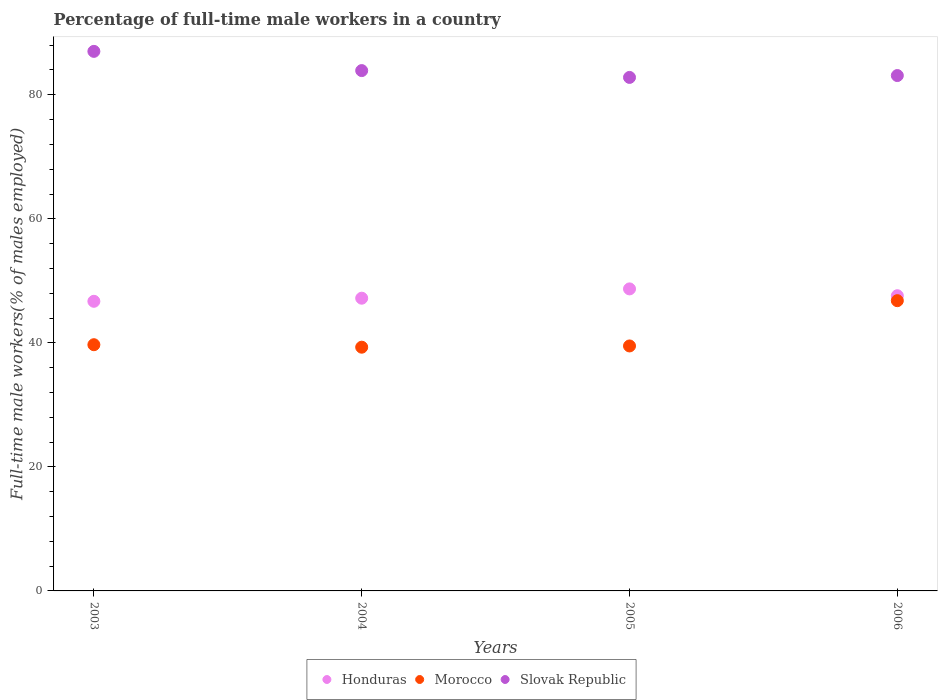How many different coloured dotlines are there?
Provide a short and direct response. 3. Is the number of dotlines equal to the number of legend labels?
Your response must be concise. Yes. What is the percentage of full-time male workers in Morocco in 2004?
Provide a short and direct response. 39.3. Across all years, what is the maximum percentage of full-time male workers in Honduras?
Keep it short and to the point. 48.7. Across all years, what is the minimum percentage of full-time male workers in Morocco?
Your answer should be compact. 39.3. In which year was the percentage of full-time male workers in Slovak Republic maximum?
Give a very brief answer. 2003. In which year was the percentage of full-time male workers in Honduras minimum?
Offer a very short reply. 2003. What is the total percentage of full-time male workers in Honduras in the graph?
Give a very brief answer. 190.2. What is the difference between the percentage of full-time male workers in Slovak Republic in 2004 and that in 2005?
Your response must be concise. 1.1. What is the difference between the percentage of full-time male workers in Morocco in 2006 and the percentage of full-time male workers in Honduras in 2005?
Your answer should be compact. -1.9. What is the average percentage of full-time male workers in Slovak Republic per year?
Provide a short and direct response. 84.2. In the year 2004, what is the difference between the percentage of full-time male workers in Honduras and percentage of full-time male workers in Morocco?
Ensure brevity in your answer.  7.9. What is the ratio of the percentage of full-time male workers in Slovak Republic in 2004 to that in 2005?
Offer a terse response. 1.01. Is the difference between the percentage of full-time male workers in Honduras in 2003 and 2004 greater than the difference between the percentage of full-time male workers in Morocco in 2003 and 2004?
Provide a short and direct response. No. What is the difference between the highest and the second highest percentage of full-time male workers in Honduras?
Provide a succinct answer. 1.1. What is the difference between the highest and the lowest percentage of full-time male workers in Slovak Republic?
Offer a very short reply. 4.2. Is the sum of the percentage of full-time male workers in Slovak Republic in 2003 and 2005 greater than the maximum percentage of full-time male workers in Honduras across all years?
Make the answer very short. Yes. Is it the case that in every year, the sum of the percentage of full-time male workers in Honduras and percentage of full-time male workers in Slovak Republic  is greater than the percentage of full-time male workers in Morocco?
Offer a terse response. Yes. Does the percentage of full-time male workers in Morocco monotonically increase over the years?
Your response must be concise. No. Is the percentage of full-time male workers in Slovak Republic strictly less than the percentage of full-time male workers in Morocco over the years?
Make the answer very short. No. How many dotlines are there?
Make the answer very short. 3. How many years are there in the graph?
Your answer should be compact. 4. What is the difference between two consecutive major ticks on the Y-axis?
Ensure brevity in your answer.  20. Does the graph contain grids?
Provide a short and direct response. No. Where does the legend appear in the graph?
Ensure brevity in your answer.  Bottom center. How are the legend labels stacked?
Your response must be concise. Horizontal. What is the title of the graph?
Provide a succinct answer. Percentage of full-time male workers in a country. Does "Guyana" appear as one of the legend labels in the graph?
Give a very brief answer. No. What is the label or title of the X-axis?
Keep it short and to the point. Years. What is the label or title of the Y-axis?
Offer a very short reply. Full-time male workers(% of males employed). What is the Full-time male workers(% of males employed) of Honduras in 2003?
Your response must be concise. 46.7. What is the Full-time male workers(% of males employed) in Morocco in 2003?
Your response must be concise. 39.7. What is the Full-time male workers(% of males employed) of Slovak Republic in 2003?
Your response must be concise. 87. What is the Full-time male workers(% of males employed) in Honduras in 2004?
Keep it short and to the point. 47.2. What is the Full-time male workers(% of males employed) in Morocco in 2004?
Offer a very short reply. 39.3. What is the Full-time male workers(% of males employed) of Slovak Republic in 2004?
Your answer should be very brief. 83.9. What is the Full-time male workers(% of males employed) in Honduras in 2005?
Give a very brief answer. 48.7. What is the Full-time male workers(% of males employed) of Morocco in 2005?
Provide a succinct answer. 39.5. What is the Full-time male workers(% of males employed) in Slovak Republic in 2005?
Your answer should be compact. 82.8. What is the Full-time male workers(% of males employed) in Honduras in 2006?
Ensure brevity in your answer.  47.6. What is the Full-time male workers(% of males employed) in Morocco in 2006?
Make the answer very short. 46.8. What is the Full-time male workers(% of males employed) of Slovak Republic in 2006?
Your answer should be compact. 83.1. Across all years, what is the maximum Full-time male workers(% of males employed) of Honduras?
Keep it short and to the point. 48.7. Across all years, what is the maximum Full-time male workers(% of males employed) in Morocco?
Provide a short and direct response. 46.8. Across all years, what is the maximum Full-time male workers(% of males employed) of Slovak Republic?
Provide a short and direct response. 87. Across all years, what is the minimum Full-time male workers(% of males employed) in Honduras?
Your answer should be compact. 46.7. Across all years, what is the minimum Full-time male workers(% of males employed) of Morocco?
Provide a short and direct response. 39.3. Across all years, what is the minimum Full-time male workers(% of males employed) in Slovak Republic?
Your answer should be compact. 82.8. What is the total Full-time male workers(% of males employed) in Honduras in the graph?
Offer a terse response. 190.2. What is the total Full-time male workers(% of males employed) in Morocco in the graph?
Give a very brief answer. 165.3. What is the total Full-time male workers(% of males employed) in Slovak Republic in the graph?
Ensure brevity in your answer.  336.8. What is the difference between the Full-time male workers(% of males employed) of Honduras in 2003 and that in 2004?
Your response must be concise. -0.5. What is the difference between the Full-time male workers(% of males employed) of Morocco in 2003 and that in 2004?
Provide a short and direct response. 0.4. What is the difference between the Full-time male workers(% of males employed) of Honduras in 2003 and that in 2005?
Make the answer very short. -2. What is the difference between the Full-time male workers(% of males employed) in Honduras in 2004 and that in 2005?
Make the answer very short. -1.5. What is the difference between the Full-time male workers(% of males employed) of Morocco in 2004 and that in 2005?
Your answer should be very brief. -0.2. What is the difference between the Full-time male workers(% of males employed) of Slovak Republic in 2004 and that in 2005?
Your answer should be very brief. 1.1. What is the difference between the Full-time male workers(% of males employed) of Morocco in 2005 and that in 2006?
Provide a short and direct response. -7.3. What is the difference between the Full-time male workers(% of males employed) of Honduras in 2003 and the Full-time male workers(% of males employed) of Morocco in 2004?
Offer a terse response. 7.4. What is the difference between the Full-time male workers(% of males employed) of Honduras in 2003 and the Full-time male workers(% of males employed) of Slovak Republic in 2004?
Give a very brief answer. -37.2. What is the difference between the Full-time male workers(% of males employed) of Morocco in 2003 and the Full-time male workers(% of males employed) of Slovak Republic in 2004?
Offer a very short reply. -44.2. What is the difference between the Full-time male workers(% of males employed) in Honduras in 2003 and the Full-time male workers(% of males employed) in Morocco in 2005?
Keep it short and to the point. 7.2. What is the difference between the Full-time male workers(% of males employed) of Honduras in 2003 and the Full-time male workers(% of males employed) of Slovak Republic in 2005?
Ensure brevity in your answer.  -36.1. What is the difference between the Full-time male workers(% of males employed) of Morocco in 2003 and the Full-time male workers(% of males employed) of Slovak Republic in 2005?
Make the answer very short. -43.1. What is the difference between the Full-time male workers(% of males employed) of Honduras in 2003 and the Full-time male workers(% of males employed) of Slovak Republic in 2006?
Keep it short and to the point. -36.4. What is the difference between the Full-time male workers(% of males employed) of Morocco in 2003 and the Full-time male workers(% of males employed) of Slovak Republic in 2006?
Give a very brief answer. -43.4. What is the difference between the Full-time male workers(% of males employed) in Honduras in 2004 and the Full-time male workers(% of males employed) in Slovak Republic in 2005?
Give a very brief answer. -35.6. What is the difference between the Full-time male workers(% of males employed) in Morocco in 2004 and the Full-time male workers(% of males employed) in Slovak Republic in 2005?
Your response must be concise. -43.5. What is the difference between the Full-time male workers(% of males employed) of Honduras in 2004 and the Full-time male workers(% of males employed) of Slovak Republic in 2006?
Your response must be concise. -35.9. What is the difference between the Full-time male workers(% of males employed) of Morocco in 2004 and the Full-time male workers(% of males employed) of Slovak Republic in 2006?
Offer a terse response. -43.8. What is the difference between the Full-time male workers(% of males employed) in Honduras in 2005 and the Full-time male workers(% of males employed) in Morocco in 2006?
Offer a terse response. 1.9. What is the difference between the Full-time male workers(% of males employed) of Honduras in 2005 and the Full-time male workers(% of males employed) of Slovak Republic in 2006?
Make the answer very short. -34.4. What is the difference between the Full-time male workers(% of males employed) of Morocco in 2005 and the Full-time male workers(% of males employed) of Slovak Republic in 2006?
Ensure brevity in your answer.  -43.6. What is the average Full-time male workers(% of males employed) of Honduras per year?
Your answer should be very brief. 47.55. What is the average Full-time male workers(% of males employed) of Morocco per year?
Provide a short and direct response. 41.33. What is the average Full-time male workers(% of males employed) in Slovak Republic per year?
Offer a very short reply. 84.2. In the year 2003, what is the difference between the Full-time male workers(% of males employed) of Honduras and Full-time male workers(% of males employed) of Slovak Republic?
Keep it short and to the point. -40.3. In the year 2003, what is the difference between the Full-time male workers(% of males employed) of Morocco and Full-time male workers(% of males employed) of Slovak Republic?
Offer a terse response. -47.3. In the year 2004, what is the difference between the Full-time male workers(% of males employed) in Honduras and Full-time male workers(% of males employed) in Morocco?
Your answer should be very brief. 7.9. In the year 2004, what is the difference between the Full-time male workers(% of males employed) in Honduras and Full-time male workers(% of males employed) in Slovak Republic?
Offer a very short reply. -36.7. In the year 2004, what is the difference between the Full-time male workers(% of males employed) of Morocco and Full-time male workers(% of males employed) of Slovak Republic?
Keep it short and to the point. -44.6. In the year 2005, what is the difference between the Full-time male workers(% of males employed) of Honduras and Full-time male workers(% of males employed) of Morocco?
Your answer should be compact. 9.2. In the year 2005, what is the difference between the Full-time male workers(% of males employed) in Honduras and Full-time male workers(% of males employed) in Slovak Republic?
Make the answer very short. -34.1. In the year 2005, what is the difference between the Full-time male workers(% of males employed) in Morocco and Full-time male workers(% of males employed) in Slovak Republic?
Ensure brevity in your answer.  -43.3. In the year 2006, what is the difference between the Full-time male workers(% of males employed) in Honduras and Full-time male workers(% of males employed) in Slovak Republic?
Your response must be concise. -35.5. In the year 2006, what is the difference between the Full-time male workers(% of males employed) of Morocco and Full-time male workers(% of males employed) of Slovak Republic?
Keep it short and to the point. -36.3. What is the ratio of the Full-time male workers(% of males employed) of Morocco in 2003 to that in 2004?
Your answer should be compact. 1.01. What is the ratio of the Full-time male workers(% of males employed) in Slovak Republic in 2003 to that in 2004?
Provide a short and direct response. 1.04. What is the ratio of the Full-time male workers(% of males employed) of Honduras in 2003 to that in 2005?
Keep it short and to the point. 0.96. What is the ratio of the Full-time male workers(% of males employed) of Slovak Republic in 2003 to that in 2005?
Make the answer very short. 1.05. What is the ratio of the Full-time male workers(% of males employed) in Honduras in 2003 to that in 2006?
Ensure brevity in your answer.  0.98. What is the ratio of the Full-time male workers(% of males employed) of Morocco in 2003 to that in 2006?
Provide a succinct answer. 0.85. What is the ratio of the Full-time male workers(% of males employed) of Slovak Republic in 2003 to that in 2006?
Provide a short and direct response. 1.05. What is the ratio of the Full-time male workers(% of males employed) of Honduras in 2004 to that in 2005?
Provide a short and direct response. 0.97. What is the ratio of the Full-time male workers(% of males employed) of Morocco in 2004 to that in 2005?
Your answer should be compact. 0.99. What is the ratio of the Full-time male workers(% of males employed) in Slovak Republic in 2004 to that in 2005?
Your answer should be very brief. 1.01. What is the ratio of the Full-time male workers(% of males employed) in Honduras in 2004 to that in 2006?
Give a very brief answer. 0.99. What is the ratio of the Full-time male workers(% of males employed) of Morocco in 2004 to that in 2006?
Ensure brevity in your answer.  0.84. What is the ratio of the Full-time male workers(% of males employed) of Slovak Republic in 2004 to that in 2006?
Ensure brevity in your answer.  1.01. What is the ratio of the Full-time male workers(% of males employed) in Honduras in 2005 to that in 2006?
Ensure brevity in your answer.  1.02. What is the ratio of the Full-time male workers(% of males employed) of Morocco in 2005 to that in 2006?
Give a very brief answer. 0.84. What is the ratio of the Full-time male workers(% of males employed) in Slovak Republic in 2005 to that in 2006?
Offer a very short reply. 1. What is the difference between the highest and the lowest Full-time male workers(% of males employed) in Honduras?
Your answer should be very brief. 2. What is the difference between the highest and the lowest Full-time male workers(% of males employed) of Morocco?
Offer a terse response. 7.5. What is the difference between the highest and the lowest Full-time male workers(% of males employed) of Slovak Republic?
Give a very brief answer. 4.2. 